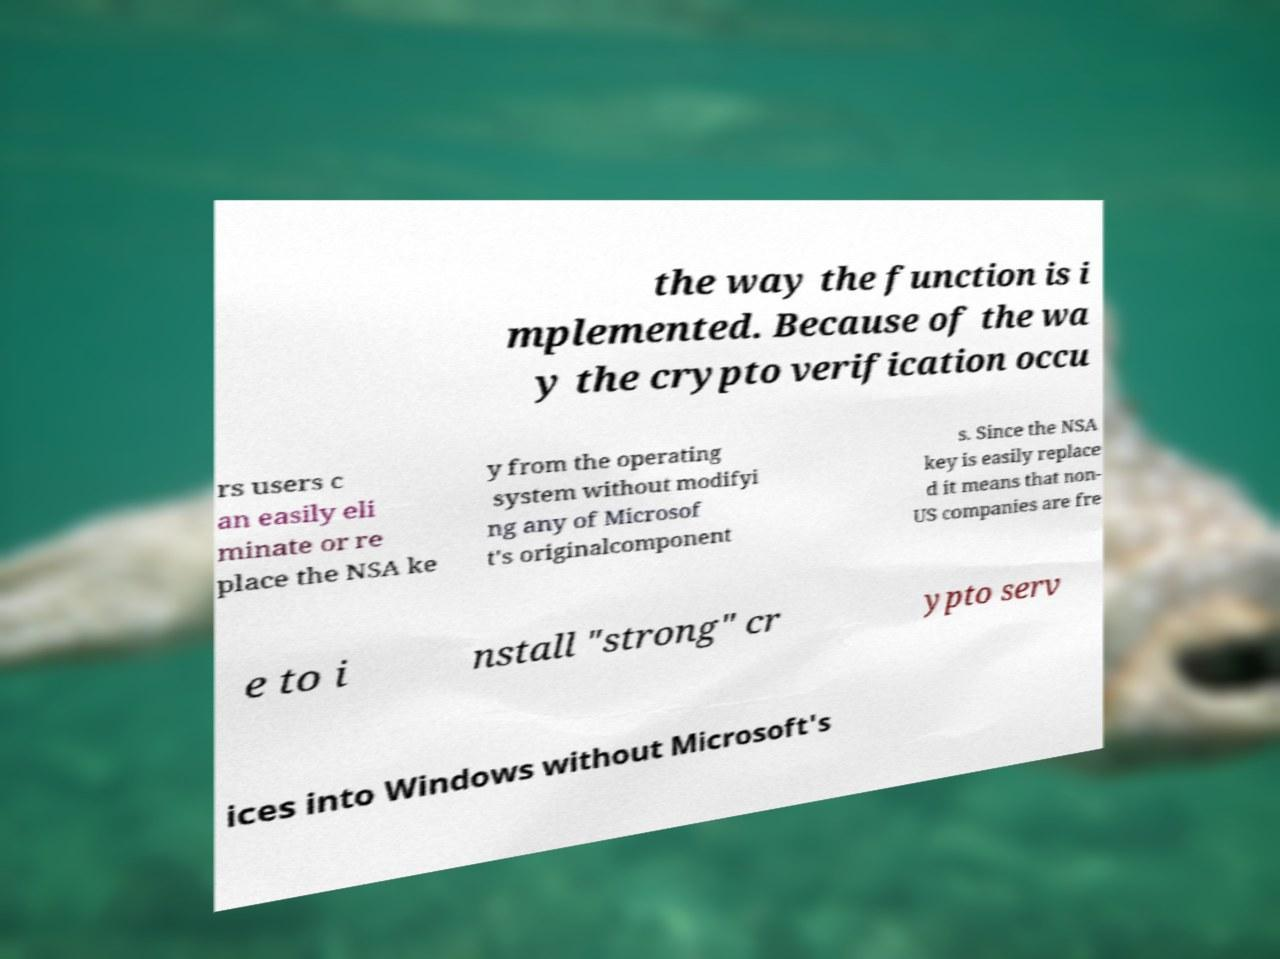Could you extract and type out the text from this image? the way the function is i mplemented. Because of the wa y the crypto verification occu rs users c an easily eli minate or re place the NSA ke y from the operating system without modifyi ng any of Microsof t's originalcomponent s. Since the NSA key is easily replace d it means that non- US companies are fre e to i nstall "strong" cr ypto serv ices into Windows without Microsoft's 